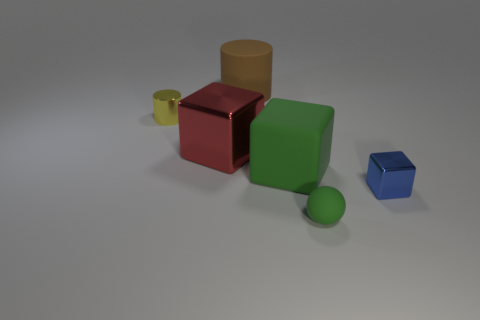Subtract all metal cubes. How many cubes are left? 1 Add 1 small green spheres. How many objects exist? 7 Subtract all cylinders. How many objects are left? 4 Subtract all metal balls. Subtract all big brown cylinders. How many objects are left? 5 Add 1 small metal things. How many small metal things are left? 3 Add 2 tiny yellow things. How many tiny yellow things exist? 3 Subtract 0 cyan blocks. How many objects are left? 6 Subtract all gray balls. Subtract all yellow cylinders. How many balls are left? 1 